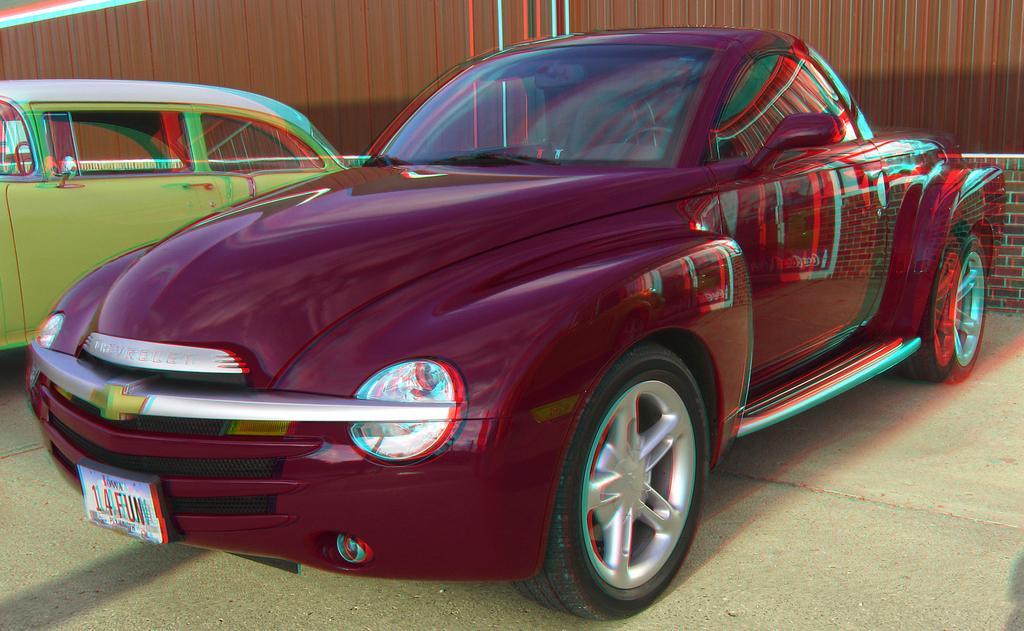Describe this image in one or two sentences. There are total of two car park,one car park at front and one back. back side is of green color front one is of maroon red. 